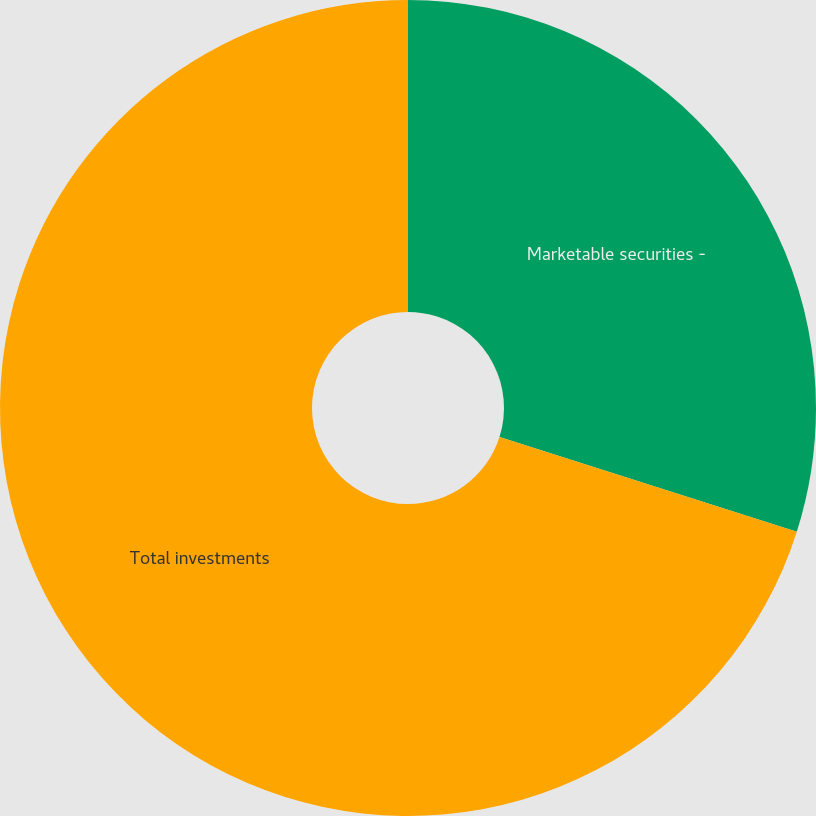Convert chart. <chart><loc_0><loc_0><loc_500><loc_500><pie_chart><fcel>Marketable securities -<fcel>Total investments<nl><fcel>29.9%<fcel>70.1%<nl></chart> 